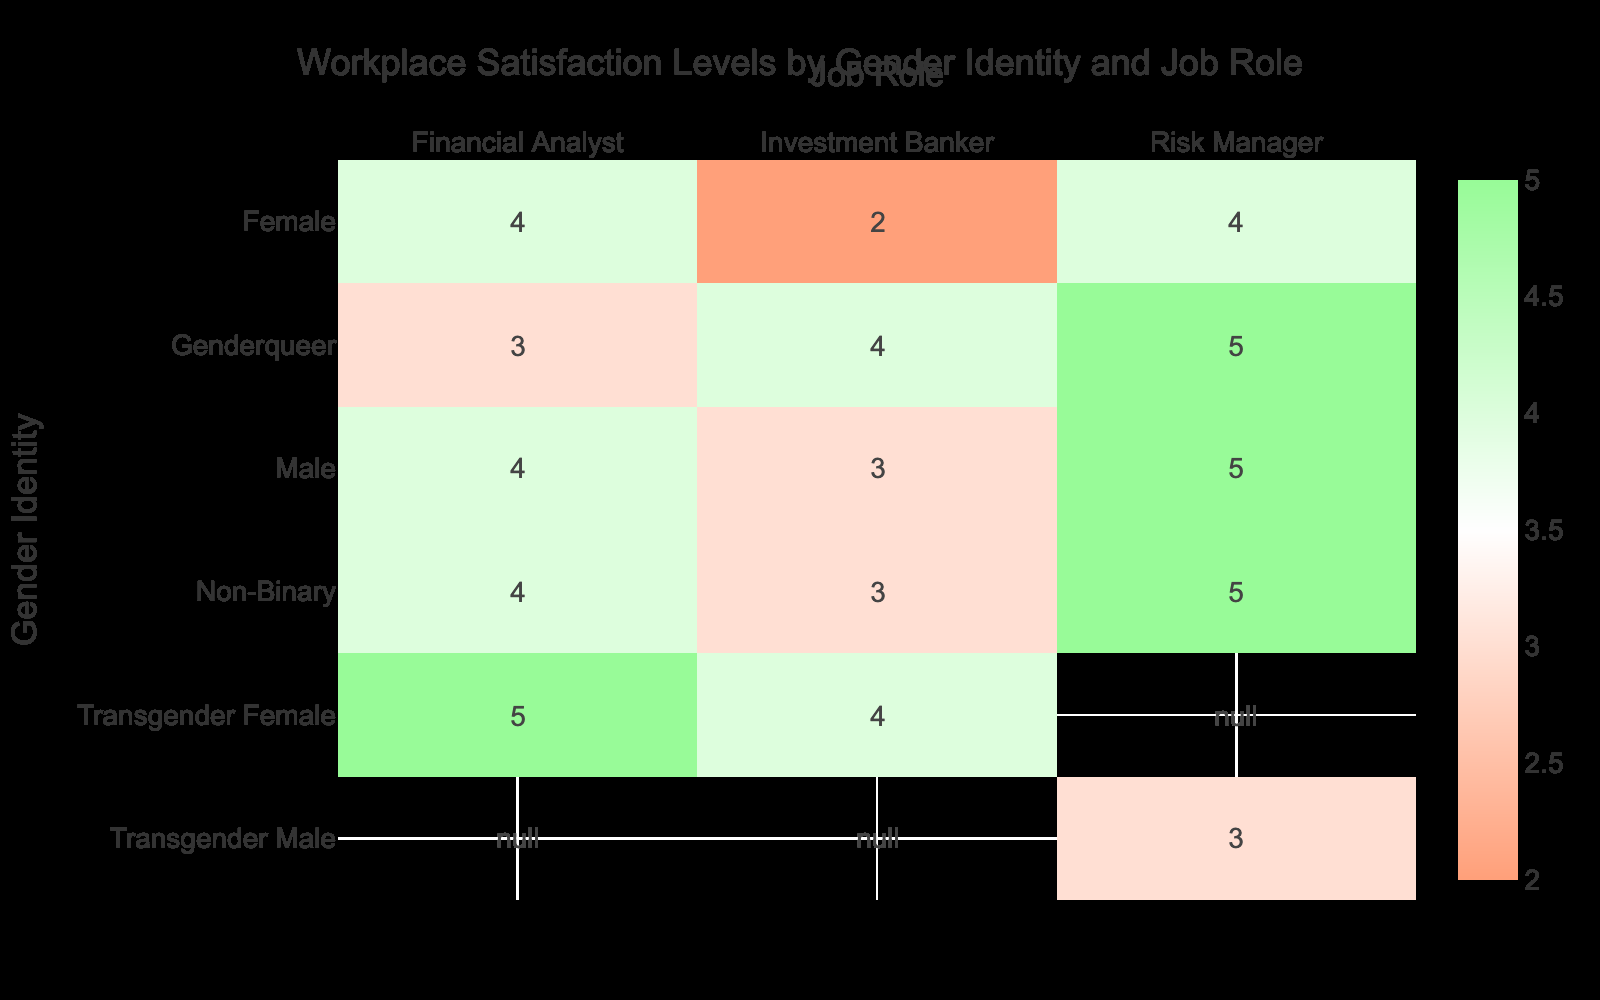What is the satisfaction level of Male Financial Analysts? The table shows that the satisfaction level for Male Financial Analysts is 4.
Answer: 4 What is the satisfaction level of the Non-Binary Risk Manager? From the table, the satisfaction level for the Non-Binary Risk Manager is 5.
Answer: 5 Is there a Gender Identity with a satisfaction level of 2? Yes, according to the table, the satisfaction level of 2 is associated with Female Investment Bankers.
Answer: Yes What is the average satisfaction level of all Job Roles combined for Transgender Females? The satisfaction levels for Transgender Females in Financial Analyst, Investment Banker, and Risk Manager roles are 5, 4, and not listed respectively. The average is calculated by summing the values (5 + 4) and dividing by 2, giving (9/2) = 4.5.
Answer: 4.5 Which Job Role has the highest satisfaction level for Genderqueer individuals? The table indicates that the highest satisfaction level for Genderqueer individuals is in the Risk Manager role, with a level of 5.
Answer: 5 How does the average satisfaction level of Non-Binary individuals compare to Male individuals? For Non-Binary individuals, the satisfaction levels are 4, 3, and 5, which sum to 12 and average to 4. For Male individuals, the satisfaction levels are 4, 3, and 5, which also sum to 12 for 3 roles, averaging to 4. So both groups have the same average satisfaction level of 4.
Answer: Same average (4) Are the satisfaction levels for Financial Analysts consistent across all Gender Identities? No, the satisfaction levels for Financial Analysts are 4 for Male and Female, 4 for Non-Binary, 5 for Transgender Female, and 3 for Genderqueer, indicating inconsistency.
Answer: No What is the satisfaction level of the highest-rated Job Role for Female professionals? From the data, the highest satisfaction level for Female professionals is 4, which is for the Financial Analyst and Risk Manager roles.
Answer: 4 